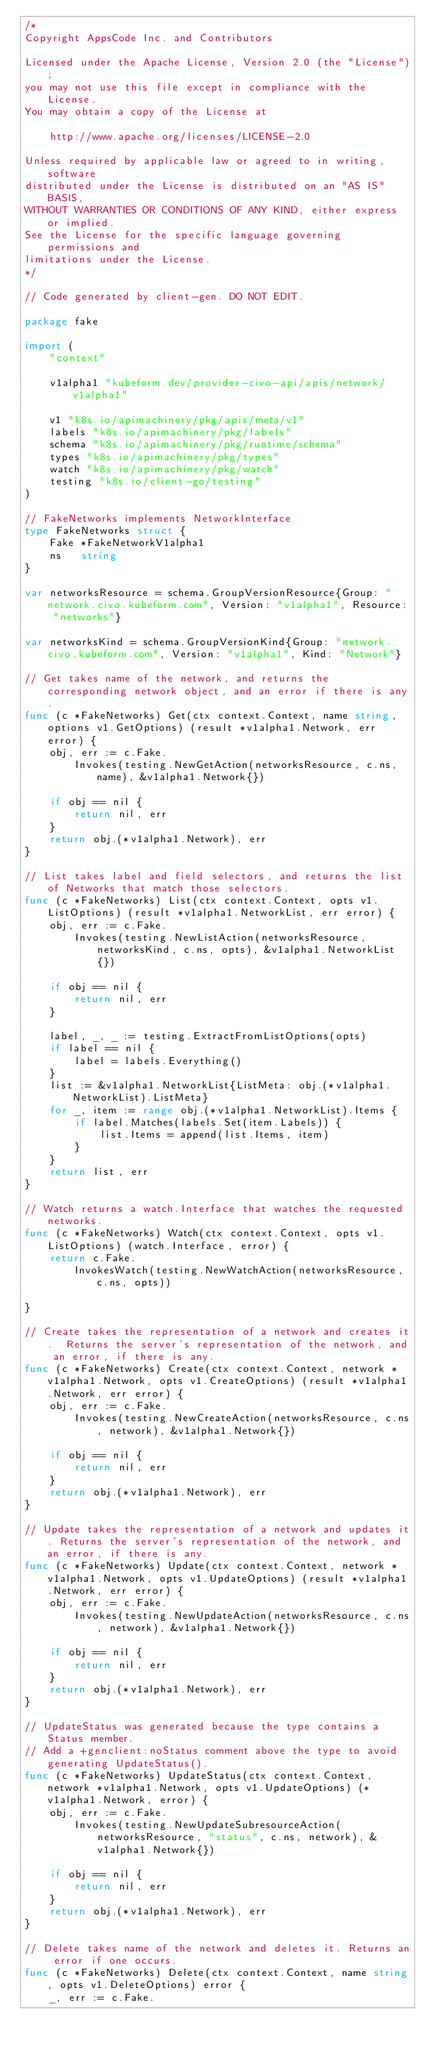Convert code to text. <code><loc_0><loc_0><loc_500><loc_500><_Go_>/*
Copyright AppsCode Inc. and Contributors

Licensed under the Apache License, Version 2.0 (the "License");
you may not use this file except in compliance with the License.
You may obtain a copy of the License at

    http://www.apache.org/licenses/LICENSE-2.0

Unless required by applicable law or agreed to in writing, software
distributed under the License is distributed on an "AS IS" BASIS,
WITHOUT WARRANTIES OR CONDITIONS OF ANY KIND, either express or implied.
See the License for the specific language governing permissions and
limitations under the License.
*/

// Code generated by client-gen. DO NOT EDIT.

package fake

import (
	"context"

	v1alpha1 "kubeform.dev/provider-civo-api/apis/network/v1alpha1"

	v1 "k8s.io/apimachinery/pkg/apis/meta/v1"
	labels "k8s.io/apimachinery/pkg/labels"
	schema "k8s.io/apimachinery/pkg/runtime/schema"
	types "k8s.io/apimachinery/pkg/types"
	watch "k8s.io/apimachinery/pkg/watch"
	testing "k8s.io/client-go/testing"
)

// FakeNetworks implements NetworkInterface
type FakeNetworks struct {
	Fake *FakeNetworkV1alpha1
	ns   string
}

var networksResource = schema.GroupVersionResource{Group: "network.civo.kubeform.com", Version: "v1alpha1", Resource: "networks"}

var networksKind = schema.GroupVersionKind{Group: "network.civo.kubeform.com", Version: "v1alpha1", Kind: "Network"}

// Get takes name of the network, and returns the corresponding network object, and an error if there is any.
func (c *FakeNetworks) Get(ctx context.Context, name string, options v1.GetOptions) (result *v1alpha1.Network, err error) {
	obj, err := c.Fake.
		Invokes(testing.NewGetAction(networksResource, c.ns, name), &v1alpha1.Network{})

	if obj == nil {
		return nil, err
	}
	return obj.(*v1alpha1.Network), err
}

// List takes label and field selectors, and returns the list of Networks that match those selectors.
func (c *FakeNetworks) List(ctx context.Context, opts v1.ListOptions) (result *v1alpha1.NetworkList, err error) {
	obj, err := c.Fake.
		Invokes(testing.NewListAction(networksResource, networksKind, c.ns, opts), &v1alpha1.NetworkList{})

	if obj == nil {
		return nil, err
	}

	label, _, _ := testing.ExtractFromListOptions(opts)
	if label == nil {
		label = labels.Everything()
	}
	list := &v1alpha1.NetworkList{ListMeta: obj.(*v1alpha1.NetworkList).ListMeta}
	for _, item := range obj.(*v1alpha1.NetworkList).Items {
		if label.Matches(labels.Set(item.Labels)) {
			list.Items = append(list.Items, item)
		}
	}
	return list, err
}

// Watch returns a watch.Interface that watches the requested networks.
func (c *FakeNetworks) Watch(ctx context.Context, opts v1.ListOptions) (watch.Interface, error) {
	return c.Fake.
		InvokesWatch(testing.NewWatchAction(networksResource, c.ns, opts))

}

// Create takes the representation of a network and creates it.  Returns the server's representation of the network, and an error, if there is any.
func (c *FakeNetworks) Create(ctx context.Context, network *v1alpha1.Network, opts v1.CreateOptions) (result *v1alpha1.Network, err error) {
	obj, err := c.Fake.
		Invokes(testing.NewCreateAction(networksResource, c.ns, network), &v1alpha1.Network{})

	if obj == nil {
		return nil, err
	}
	return obj.(*v1alpha1.Network), err
}

// Update takes the representation of a network and updates it. Returns the server's representation of the network, and an error, if there is any.
func (c *FakeNetworks) Update(ctx context.Context, network *v1alpha1.Network, opts v1.UpdateOptions) (result *v1alpha1.Network, err error) {
	obj, err := c.Fake.
		Invokes(testing.NewUpdateAction(networksResource, c.ns, network), &v1alpha1.Network{})

	if obj == nil {
		return nil, err
	}
	return obj.(*v1alpha1.Network), err
}

// UpdateStatus was generated because the type contains a Status member.
// Add a +genclient:noStatus comment above the type to avoid generating UpdateStatus().
func (c *FakeNetworks) UpdateStatus(ctx context.Context, network *v1alpha1.Network, opts v1.UpdateOptions) (*v1alpha1.Network, error) {
	obj, err := c.Fake.
		Invokes(testing.NewUpdateSubresourceAction(networksResource, "status", c.ns, network), &v1alpha1.Network{})

	if obj == nil {
		return nil, err
	}
	return obj.(*v1alpha1.Network), err
}

// Delete takes name of the network and deletes it. Returns an error if one occurs.
func (c *FakeNetworks) Delete(ctx context.Context, name string, opts v1.DeleteOptions) error {
	_, err := c.Fake.</code> 